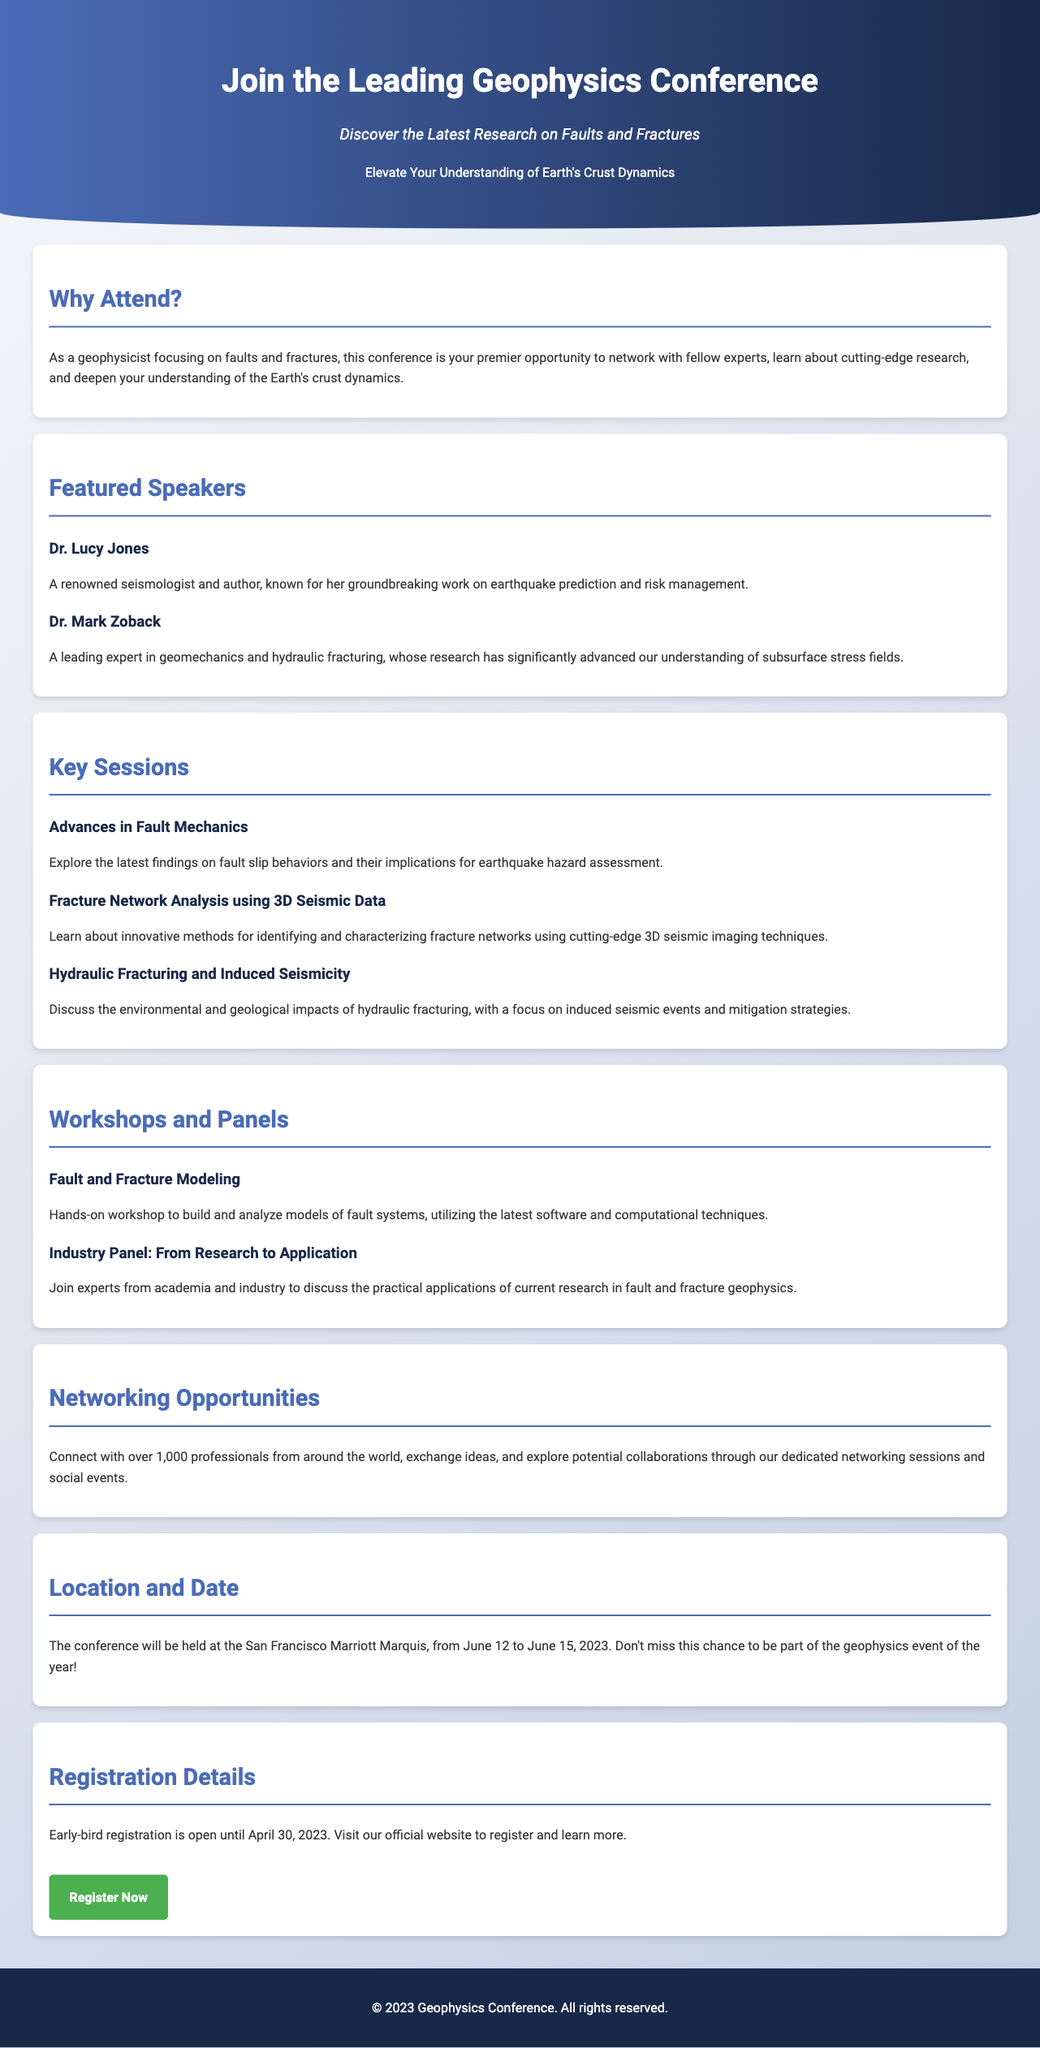What is the conference date? The conference will be held from June 12 to June 15, 2023 as stated in the document.
Answer: June 12 to June 15, 2023 Who is a featured speaker known for earthquake prediction? Dr. Lucy Jones is recognized for her work on earthquake prediction and risk management.
Answer: Dr. Lucy Jones What is the location of the conference? The document mentions that the conference will take place at the San Francisco Marriott Marquis.
Answer: San Francisco Marriott Marquis What is the title of the hands-on workshop? The hands-on workshop is titled "Fault and Fracture Modeling."
Answer: Fault and Fracture Modeling When does early-bird registration end? Early-bird registration is open until April 30, 2023 as per the registration details section.
Answer: April 30, 2023 What is the total number of professionals expected to attend? The document indicates that over 1,000 professionals will be present at the conference.
Answer: Over 1,000 What session focuses on 3D seismic data? The session titled "Fracture Network Analysis using 3D Seismic Data" specifically addresses this topic.
Answer: Fracture Network Analysis using 3D Seismic Data What is a key topic discussed related to hydraulic fracturing? The session on hydraulic fracturing discusses environmental and geological impacts, including induced seismic events.
Answer: Environmental and geological impacts What is the purpose of this conference? The primary purpose is to network with fellow experts and learn about cutting-edge research on faults and fractures.
Answer: Network and learn about cutting-edge research 